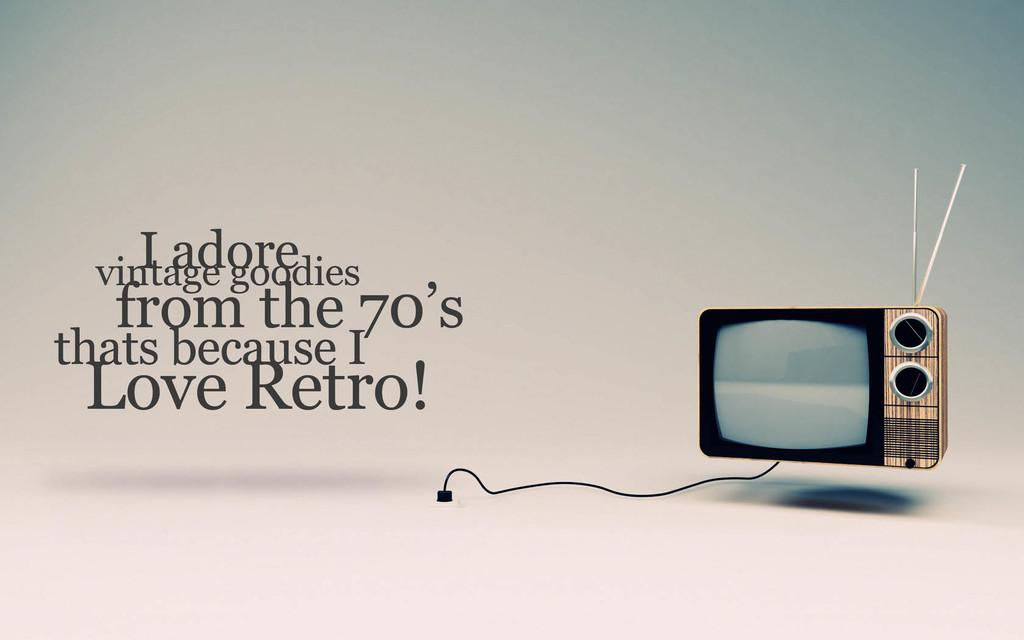<image>
Present a compact description of the photo's key features. A retro TV is adored by someone who loves vintage goodies from the 70's. 